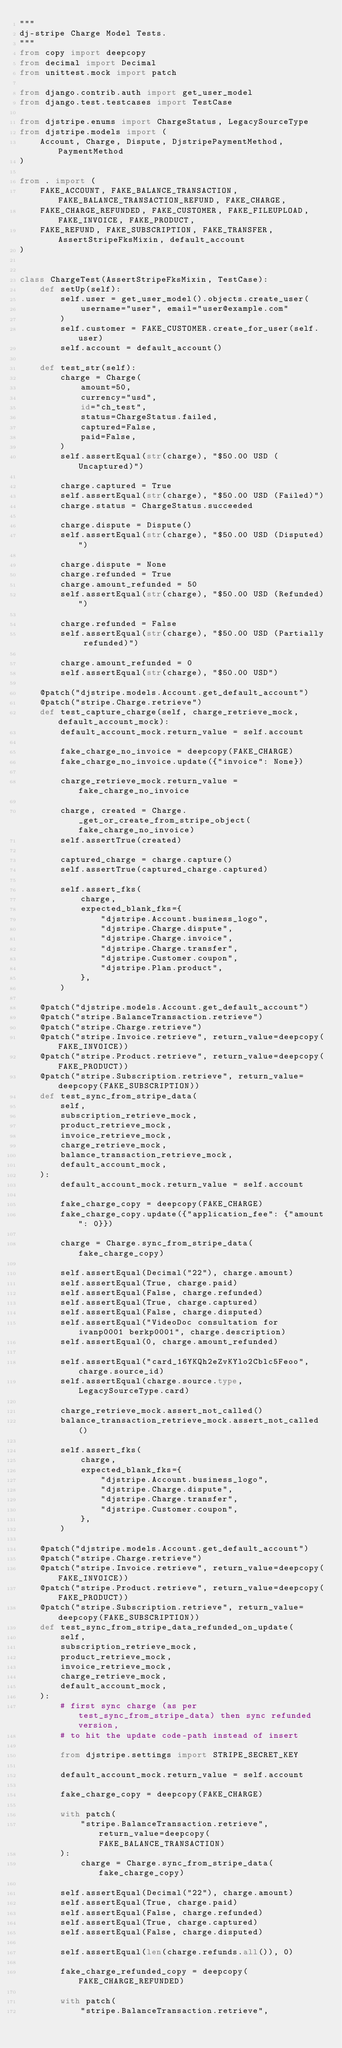<code> <loc_0><loc_0><loc_500><loc_500><_Python_>"""
dj-stripe Charge Model Tests.
"""
from copy import deepcopy
from decimal import Decimal
from unittest.mock import patch

from django.contrib.auth import get_user_model
from django.test.testcases import TestCase

from djstripe.enums import ChargeStatus, LegacySourceType
from djstripe.models import (
	Account, Charge, Dispute, DjstripePaymentMethod, PaymentMethod
)

from . import (
	FAKE_ACCOUNT, FAKE_BALANCE_TRANSACTION, FAKE_BALANCE_TRANSACTION_REFUND, FAKE_CHARGE,
	FAKE_CHARGE_REFUNDED, FAKE_CUSTOMER, FAKE_FILEUPLOAD, FAKE_INVOICE, FAKE_PRODUCT,
	FAKE_REFUND, FAKE_SUBSCRIPTION, FAKE_TRANSFER, AssertStripeFksMixin, default_account
)


class ChargeTest(AssertStripeFksMixin, TestCase):
	def setUp(self):
		self.user = get_user_model().objects.create_user(
			username="user", email="user@example.com"
		)
		self.customer = FAKE_CUSTOMER.create_for_user(self.user)
		self.account = default_account()

	def test_str(self):
		charge = Charge(
			amount=50,
			currency="usd",
			id="ch_test",
			status=ChargeStatus.failed,
			captured=False,
			paid=False,
		)
		self.assertEqual(str(charge), "$50.00 USD (Uncaptured)")

		charge.captured = True
		self.assertEqual(str(charge), "$50.00 USD (Failed)")
		charge.status = ChargeStatus.succeeded

		charge.dispute = Dispute()
		self.assertEqual(str(charge), "$50.00 USD (Disputed)")

		charge.dispute = None
		charge.refunded = True
		charge.amount_refunded = 50
		self.assertEqual(str(charge), "$50.00 USD (Refunded)")

		charge.refunded = False
		self.assertEqual(str(charge), "$50.00 USD (Partially refunded)")

		charge.amount_refunded = 0
		self.assertEqual(str(charge), "$50.00 USD")

	@patch("djstripe.models.Account.get_default_account")
	@patch("stripe.Charge.retrieve")
	def test_capture_charge(self, charge_retrieve_mock, default_account_mock):
		default_account_mock.return_value = self.account

		fake_charge_no_invoice = deepcopy(FAKE_CHARGE)
		fake_charge_no_invoice.update({"invoice": None})

		charge_retrieve_mock.return_value = fake_charge_no_invoice

		charge, created = Charge._get_or_create_from_stripe_object(fake_charge_no_invoice)
		self.assertTrue(created)

		captured_charge = charge.capture()
		self.assertTrue(captured_charge.captured)

		self.assert_fks(
			charge,
			expected_blank_fks={
				"djstripe.Account.business_logo",
				"djstripe.Charge.dispute",
				"djstripe.Charge.invoice",
				"djstripe.Charge.transfer",
				"djstripe.Customer.coupon",
				"djstripe.Plan.product",
			},
		)

	@patch("djstripe.models.Account.get_default_account")
	@patch("stripe.BalanceTransaction.retrieve")
	@patch("stripe.Charge.retrieve")
	@patch("stripe.Invoice.retrieve", return_value=deepcopy(FAKE_INVOICE))
	@patch("stripe.Product.retrieve", return_value=deepcopy(FAKE_PRODUCT))
	@patch("stripe.Subscription.retrieve", return_value=deepcopy(FAKE_SUBSCRIPTION))
	def test_sync_from_stripe_data(
		self,
		subscription_retrieve_mock,
		product_retrieve_mock,
		invoice_retrieve_mock,
		charge_retrieve_mock,
		balance_transaction_retrieve_mock,
		default_account_mock,
	):
		default_account_mock.return_value = self.account

		fake_charge_copy = deepcopy(FAKE_CHARGE)
		fake_charge_copy.update({"application_fee": {"amount": 0}})

		charge = Charge.sync_from_stripe_data(fake_charge_copy)

		self.assertEqual(Decimal("22"), charge.amount)
		self.assertEqual(True, charge.paid)
		self.assertEqual(False, charge.refunded)
		self.assertEqual(True, charge.captured)
		self.assertEqual(False, charge.disputed)
		self.assertEqual("VideoDoc consultation for ivanp0001 berkp0001", charge.description)
		self.assertEqual(0, charge.amount_refunded)

		self.assertEqual("card_16YKQh2eZvKYlo2Cblc5Feoo", charge.source_id)
		self.assertEqual(charge.source.type, LegacySourceType.card)

		charge_retrieve_mock.assert_not_called()
		balance_transaction_retrieve_mock.assert_not_called()

		self.assert_fks(
			charge,
			expected_blank_fks={
				"djstripe.Account.business_logo",
				"djstripe.Charge.dispute",
				"djstripe.Charge.transfer",
				"djstripe.Customer.coupon",
			},
		)

	@patch("djstripe.models.Account.get_default_account")
	@patch("stripe.Charge.retrieve")
	@patch("stripe.Invoice.retrieve", return_value=deepcopy(FAKE_INVOICE))
	@patch("stripe.Product.retrieve", return_value=deepcopy(FAKE_PRODUCT))
	@patch("stripe.Subscription.retrieve", return_value=deepcopy(FAKE_SUBSCRIPTION))
	def test_sync_from_stripe_data_refunded_on_update(
		self,
		subscription_retrieve_mock,
		product_retrieve_mock,
		invoice_retrieve_mock,
		charge_retrieve_mock,
		default_account_mock,
	):
		# first sync charge (as per test_sync_from_stripe_data) then sync refunded version,
		# to hit the update code-path instead of insert

		from djstripe.settings import STRIPE_SECRET_KEY

		default_account_mock.return_value = self.account

		fake_charge_copy = deepcopy(FAKE_CHARGE)

		with patch(
			"stripe.BalanceTransaction.retrieve", return_value=deepcopy(FAKE_BALANCE_TRANSACTION)
		):
			charge = Charge.sync_from_stripe_data(fake_charge_copy)

		self.assertEqual(Decimal("22"), charge.amount)
		self.assertEqual(True, charge.paid)
		self.assertEqual(False, charge.refunded)
		self.assertEqual(True, charge.captured)
		self.assertEqual(False, charge.disputed)

		self.assertEqual(len(charge.refunds.all()), 0)

		fake_charge_refunded_copy = deepcopy(FAKE_CHARGE_REFUNDED)

		with patch(
			"stripe.BalanceTransaction.retrieve",</code> 